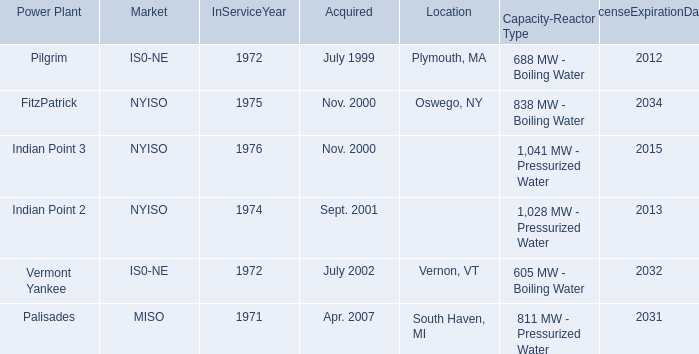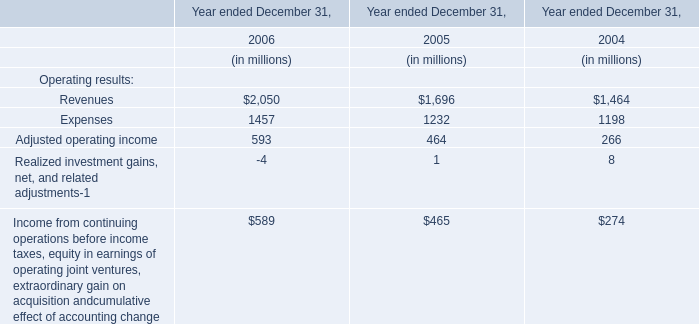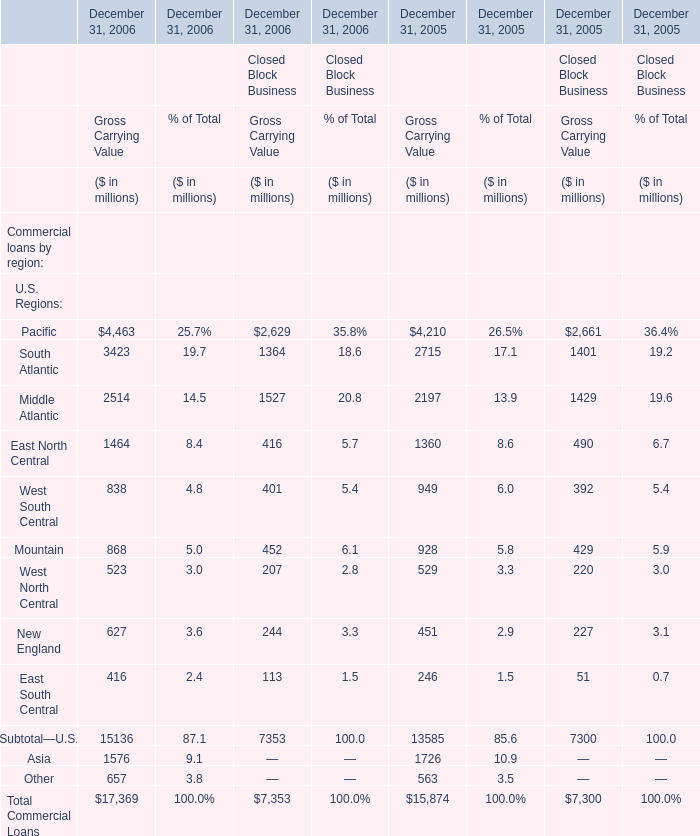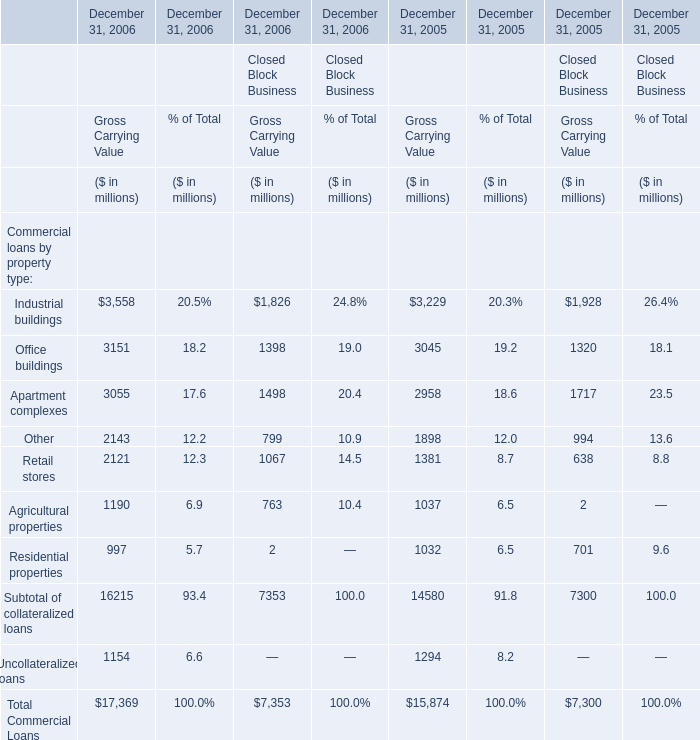What is the total value of Industrial buildings Office buildings Apartment complexes Other in 2006 for Gross Carrying Value for Financial Services Businesses? (in million) 
Computations: (((3558 + 3151) + 3055) + 2143)
Answer: 11907.0. 